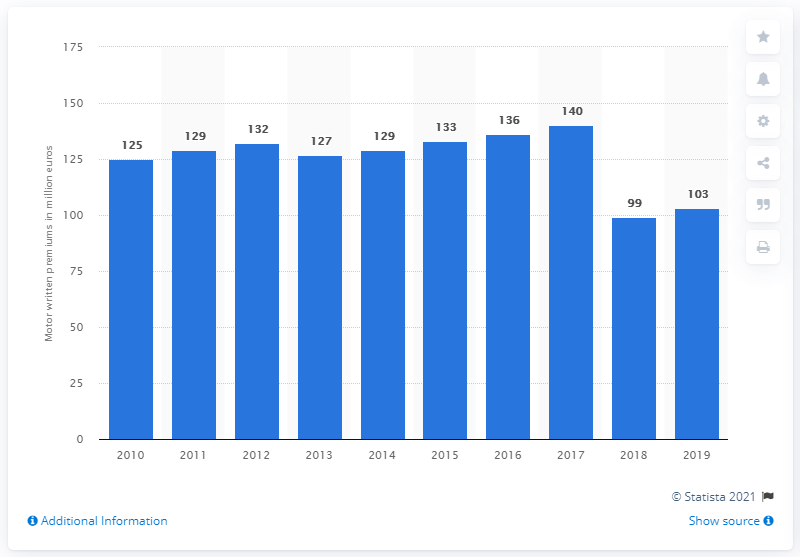Outline some significant characteristics in this image. The value of written motor insurance premiums in 2018 was 99. In 2017, the total amount of written motor insurance premiums for all European countries was 140.. The motor insurance market began to increase in the year 2013. 